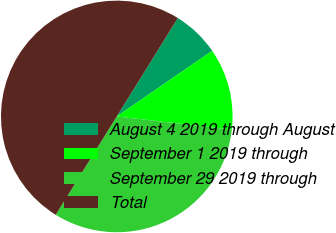Convert chart. <chart><loc_0><loc_0><loc_500><loc_500><pie_chart><fcel>August 4 2019 through August<fcel>September 1 2019 through<fcel>September 29 2019 through<fcel>Total<nl><fcel>6.57%<fcel>11.41%<fcel>32.02%<fcel>50.0%<nl></chart> 